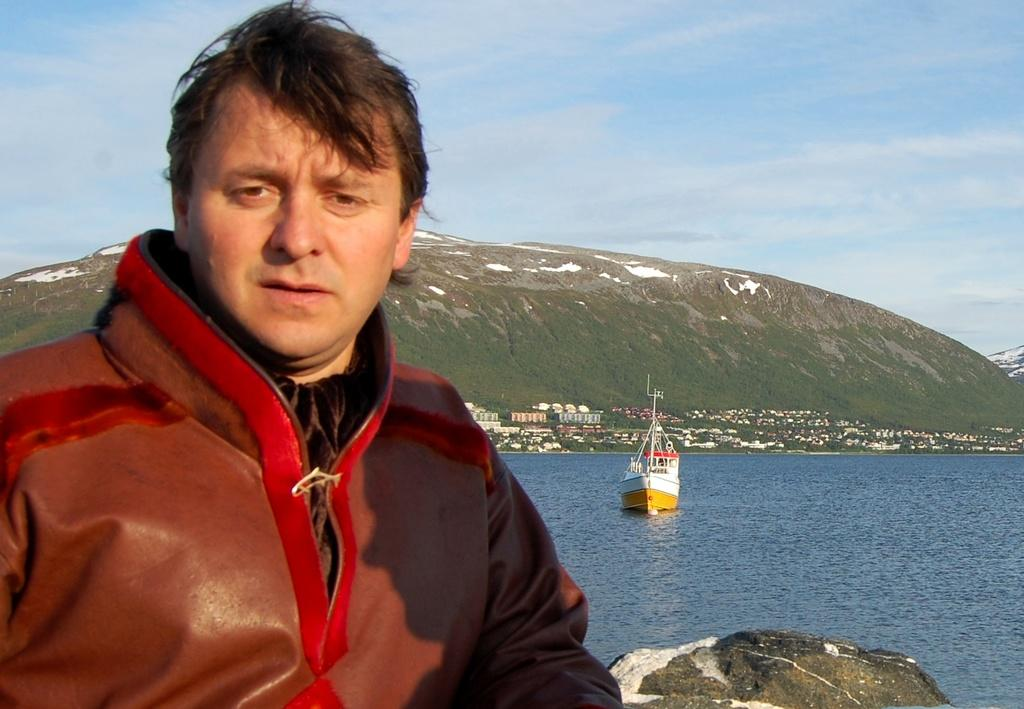Who is present in the image? There is a man in the image. What is located on the water in the image? There is a boat on the water in the image. What type of natural feature can be seen in the image? There are rocks in the image. What type of man-made structures are visible in the image? There are buildings in the image. What type of vegetation is present in the image? There is grass in the image. What type of large landform is visible in the image? There is a mountain in the image. What is visible in the background of the image? The sky is visible in the background of the image. What type of weather can be inferred from the image? There are clouds in the sky, suggesting that the weather might be partly cloudy. What type of jail can be seen in the image? There is no jail present in the image. What type of war is depicted in the image? There is no war depicted in the image. 